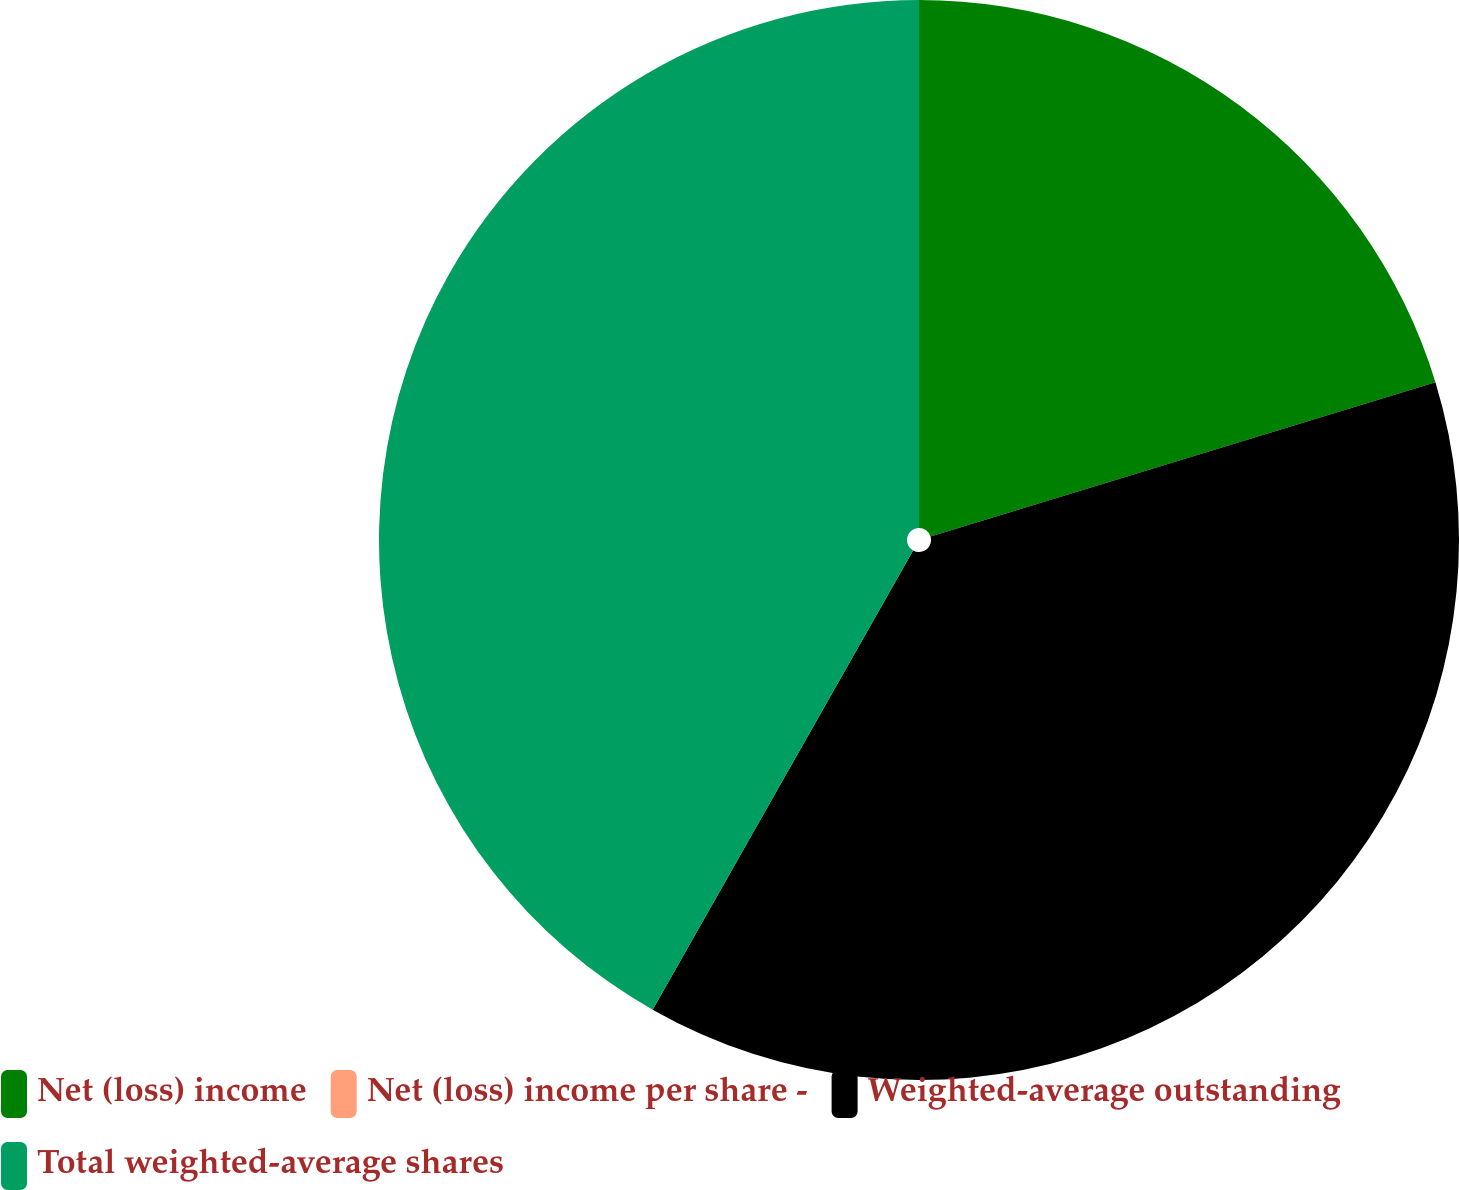Convert chart. <chart><loc_0><loc_0><loc_500><loc_500><pie_chart><fcel>Net (loss) income<fcel>Net (loss) income per share -<fcel>Weighted-average outstanding<fcel>Total weighted-average shares<nl><fcel>20.28%<fcel>0.0%<fcel>37.93%<fcel>41.79%<nl></chart> 